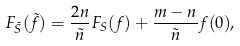Convert formula to latex. <formula><loc_0><loc_0><loc_500><loc_500>F _ { \tilde { S } } ( \tilde { f } ) = \frac { 2 n } { \tilde { n } } F _ { S } ( f ) + \frac { m - n } { \tilde { n } } f ( 0 ) ,</formula> 